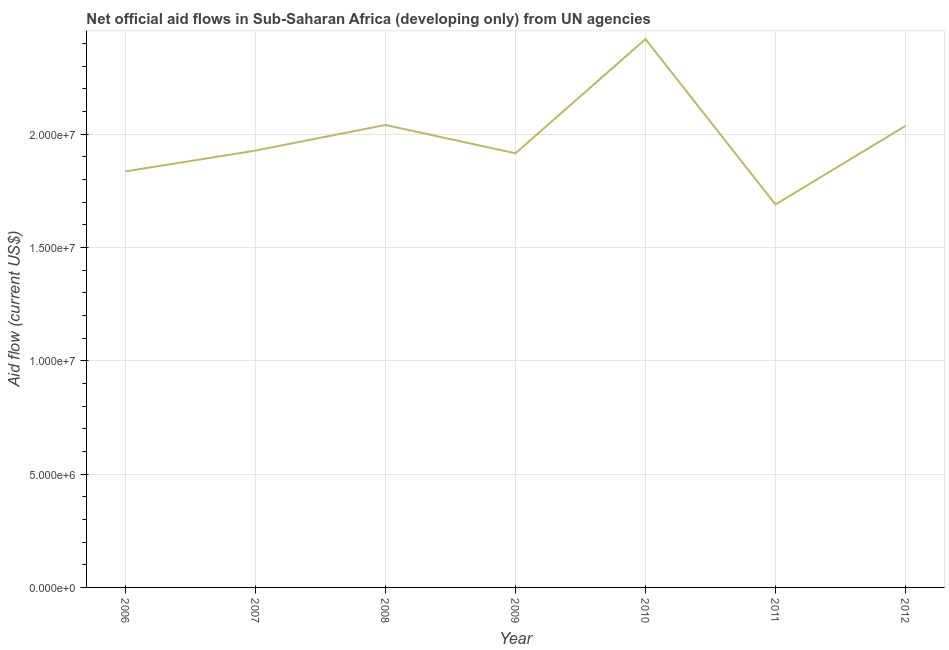What is the net official flows from un agencies in 2006?
Give a very brief answer. 1.84e+07. Across all years, what is the maximum net official flows from un agencies?
Your answer should be very brief. 2.42e+07. Across all years, what is the minimum net official flows from un agencies?
Provide a succinct answer. 1.69e+07. In which year was the net official flows from un agencies maximum?
Offer a very short reply. 2010. In which year was the net official flows from un agencies minimum?
Make the answer very short. 2011. What is the sum of the net official flows from un agencies?
Ensure brevity in your answer.  1.39e+08. What is the difference between the net official flows from un agencies in 2007 and 2008?
Your response must be concise. -1.13e+06. What is the average net official flows from un agencies per year?
Keep it short and to the point. 1.98e+07. What is the median net official flows from un agencies?
Make the answer very short. 1.93e+07. Do a majority of the years between 2011 and 2007 (inclusive) have net official flows from un agencies greater than 10000000 US$?
Give a very brief answer. Yes. What is the ratio of the net official flows from un agencies in 2008 to that in 2011?
Offer a terse response. 1.21. Is the difference between the net official flows from un agencies in 2007 and 2011 greater than the difference between any two years?
Offer a very short reply. No. What is the difference between the highest and the second highest net official flows from un agencies?
Give a very brief answer. 3.79e+06. Is the sum of the net official flows from un agencies in 2007 and 2012 greater than the maximum net official flows from un agencies across all years?
Keep it short and to the point. Yes. What is the difference between the highest and the lowest net official flows from un agencies?
Give a very brief answer. 7.30e+06. In how many years, is the net official flows from un agencies greater than the average net official flows from un agencies taken over all years?
Offer a very short reply. 3. How many lines are there?
Provide a short and direct response. 1. Are the values on the major ticks of Y-axis written in scientific E-notation?
Your response must be concise. Yes. Does the graph contain any zero values?
Provide a short and direct response. No. What is the title of the graph?
Your response must be concise. Net official aid flows in Sub-Saharan Africa (developing only) from UN agencies. What is the label or title of the X-axis?
Offer a terse response. Year. What is the label or title of the Y-axis?
Provide a succinct answer. Aid flow (current US$). What is the Aid flow (current US$) of 2006?
Your response must be concise. 1.84e+07. What is the Aid flow (current US$) of 2007?
Your answer should be very brief. 1.93e+07. What is the Aid flow (current US$) of 2008?
Make the answer very short. 2.04e+07. What is the Aid flow (current US$) in 2009?
Provide a short and direct response. 1.92e+07. What is the Aid flow (current US$) of 2010?
Give a very brief answer. 2.42e+07. What is the Aid flow (current US$) in 2011?
Make the answer very short. 1.69e+07. What is the Aid flow (current US$) in 2012?
Your answer should be very brief. 2.04e+07. What is the difference between the Aid flow (current US$) in 2006 and 2007?
Make the answer very short. -9.20e+05. What is the difference between the Aid flow (current US$) in 2006 and 2008?
Your response must be concise. -2.05e+06. What is the difference between the Aid flow (current US$) in 2006 and 2009?
Your answer should be very brief. -8.00e+05. What is the difference between the Aid flow (current US$) in 2006 and 2010?
Your answer should be very brief. -5.84e+06. What is the difference between the Aid flow (current US$) in 2006 and 2011?
Your answer should be very brief. 1.46e+06. What is the difference between the Aid flow (current US$) in 2006 and 2012?
Keep it short and to the point. -2.01e+06. What is the difference between the Aid flow (current US$) in 2007 and 2008?
Provide a short and direct response. -1.13e+06. What is the difference between the Aid flow (current US$) in 2007 and 2009?
Keep it short and to the point. 1.20e+05. What is the difference between the Aid flow (current US$) in 2007 and 2010?
Give a very brief answer. -4.92e+06. What is the difference between the Aid flow (current US$) in 2007 and 2011?
Your answer should be very brief. 2.38e+06. What is the difference between the Aid flow (current US$) in 2007 and 2012?
Make the answer very short. -1.09e+06. What is the difference between the Aid flow (current US$) in 2008 and 2009?
Your answer should be very brief. 1.25e+06. What is the difference between the Aid flow (current US$) in 2008 and 2010?
Offer a very short reply. -3.79e+06. What is the difference between the Aid flow (current US$) in 2008 and 2011?
Offer a very short reply. 3.51e+06. What is the difference between the Aid flow (current US$) in 2008 and 2012?
Ensure brevity in your answer.  4.00e+04. What is the difference between the Aid flow (current US$) in 2009 and 2010?
Your answer should be very brief. -5.04e+06. What is the difference between the Aid flow (current US$) in 2009 and 2011?
Your response must be concise. 2.26e+06. What is the difference between the Aid flow (current US$) in 2009 and 2012?
Make the answer very short. -1.21e+06. What is the difference between the Aid flow (current US$) in 2010 and 2011?
Your answer should be very brief. 7.30e+06. What is the difference between the Aid flow (current US$) in 2010 and 2012?
Provide a short and direct response. 3.83e+06. What is the difference between the Aid flow (current US$) in 2011 and 2012?
Your answer should be compact. -3.47e+06. What is the ratio of the Aid flow (current US$) in 2006 to that in 2007?
Make the answer very short. 0.95. What is the ratio of the Aid flow (current US$) in 2006 to that in 2009?
Keep it short and to the point. 0.96. What is the ratio of the Aid flow (current US$) in 2006 to that in 2010?
Offer a very short reply. 0.76. What is the ratio of the Aid flow (current US$) in 2006 to that in 2011?
Provide a short and direct response. 1.09. What is the ratio of the Aid flow (current US$) in 2006 to that in 2012?
Your answer should be compact. 0.9. What is the ratio of the Aid flow (current US$) in 2007 to that in 2008?
Provide a short and direct response. 0.94. What is the ratio of the Aid flow (current US$) in 2007 to that in 2010?
Your answer should be very brief. 0.8. What is the ratio of the Aid flow (current US$) in 2007 to that in 2011?
Your response must be concise. 1.14. What is the ratio of the Aid flow (current US$) in 2007 to that in 2012?
Offer a very short reply. 0.95. What is the ratio of the Aid flow (current US$) in 2008 to that in 2009?
Your answer should be very brief. 1.06. What is the ratio of the Aid flow (current US$) in 2008 to that in 2010?
Offer a terse response. 0.84. What is the ratio of the Aid flow (current US$) in 2008 to that in 2011?
Your response must be concise. 1.21. What is the ratio of the Aid flow (current US$) in 2008 to that in 2012?
Your answer should be very brief. 1. What is the ratio of the Aid flow (current US$) in 2009 to that in 2010?
Keep it short and to the point. 0.79. What is the ratio of the Aid flow (current US$) in 2009 to that in 2011?
Your answer should be compact. 1.13. What is the ratio of the Aid flow (current US$) in 2009 to that in 2012?
Make the answer very short. 0.94. What is the ratio of the Aid flow (current US$) in 2010 to that in 2011?
Give a very brief answer. 1.43. What is the ratio of the Aid flow (current US$) in 2010 to that in 2012?
Make the answer very short. 1.19. What is the ratio of the Aid flow (current US$) in 2011 to that in 2012?
Offer a very short reply. 0.83. 